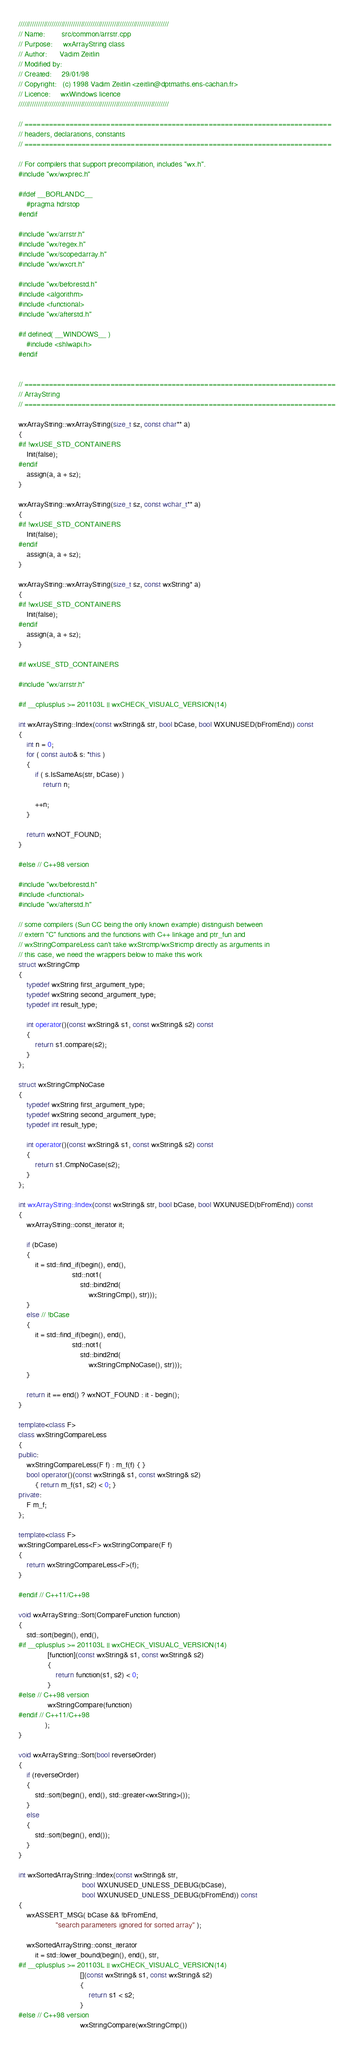<code> <loc_0><loc_0><loc_500><loc_500><_C++_>/////////////////////////////////////////////////////////////////////////////
// Name:        src/common/arrstr.cpp
// Purpose:     wxArrayString class
// Author:      Vadim Zeitlin
// Modified by:
// Created:     29/01/98
// Copyright:   (c) 1998 Vadim Zeitlin <zeitlin@dptmaths.ens-cachan.fr>
// Licence:     wxWindows licence
/////////////////////////////////////////////////////////////////////////////

// ===========================================================================
// headers, declarations, constants
// ===========================================================================

// For compilers that support precompilation, includes "wx.h".
#include "wx/wxprec.h"

#ifdef __BORLANDC__
    #pragma hdrstop
#endif

#include "wx/arrstr.h"
#include "wx/regex.h"
#include "wx/scopedarray.h"
#include "wx/wxcrt.h"

#include "wx/beforestd.h"
#include <algorithm>
#include <functional>
#include "wx/afterstd.h"

#if defined( __WINDOWS__ )
    #include <shlwapi.h>
#endif


// ============================================================================
// ArrayString
// ============================================================================

wxArrayString::wxArrayString(size_t sz, const char** a)
{
#if !wxUSE_STD_CONTAINERS
    Init(false);
#endif
    assign(a, a + sz);
}

wxArrayString::wxArrayString(size_t sz, const wchar_t** a)
{
#if !wxUSE_STD_CONTAINERS
    Init(false);
#endif
    assign(a, a + sz);
}

wxArrayString::wxArrayString(size_t sz, const wxString* a)
{
#if !wxUSE_STD_CONTAINERS
    Init(false);
#endif
    assign(a, a + sz);
}

#if wxUSE_STD_CONTAINERS

#include "wx/arrstr.h"

#if __cplusplus >= 201103L || wxCHECK_VISUALC_VERSION(14)

int wxArrayString::Index(const wxString& str, bool bCase, bool WXUNUSED(bFromEnd)) const
{
    int n = 0;
    for ( const auto& s: *this )
    {
        if ( s.IsSameAs(str, bCase) )
            return n;

        ++n;
    }

    return wxNOT_FOUND;
}

#else // C++98 version

#include "wx/beforestd.h"
#include <functional>
#include "wx/afterstd.h"

// some compilers (Sun CC being the only known example) distinguish between
// extern "C" functions and the functions with C++ linkage and ptr_fun and
// wxStringCompareLess can't take wxStrcmp/wxStricmp directly as arguments in
// this case, we need the wrappers below to make this work
struct wxStringCmp
{
    typedef wxString first_argument_type;
    typedef wxString second_argument_type;
    typedef int result_type;

    int operator()(const wxString& s1, const wxString& s2) const
    {
        return s1.compare(s2);
    }
};

struct wxStringCmpNoCase
{
    typedef wxString first_argument_type;
    typedef wxString second_argument_type;
    typedef int result_type;

    int operator()(const wxString& s1, const wxString& s2) const
    {
        return s1.CmpNoCase(s2);
    }
};

int wxArrayString::Index(const wxString& str, bool bCase, bool WXUNUSED(bFromEnd)) const
{
    wxArrayString::const_iterator it;

    if (bCase)
    {
        it = std::find_if(begin(), end(),
                          std::not1(
                              std::bind2nd(
                                  wxStringCmp(), str)));
    }
    else // !bCase
    {
        it = std::find_if(begin(), end(),
                          std::not1(
                              std::bind2nd(
                                  wxStringCmpNoCase(), str)));
    }

    return it == end() ? wxNOT_FOUND : it - begin();
}

template<class F>
class wxStringCompareLess
{
public:
    wxStringCompareLess(F f) : m_f(f) { }
    bool operator()(const wxString& s1, const wxString& s2)
        { return m_f(s1, s2) < 0; }
private:
    F m_f;
};

template<class F>
wxStringCompareLess<F> wxStringCompare(F f)
{
    return wxStringCompareLess<F>(f);
}

#endif // C++11/C++98

void wxArrayString::Sort(CompareFunction function)
{
    std::sort(begin(), end(),
#if __cplusplus >= 201103L || wxCHECK_VISUALC_VERSION(14)
              [function](const wxString& s1, const wxString& s2)
              {
                  return function(s1, s2) < 0;
              }
#else // C++98 version
              wxStringCompare(function)
#endif // C++11/C++98
             );
}

void wxArrayString::Sort(bool reverseOrder)
{
    if (reverseOrder)
    {
        std::sort(begin(), end(), std::greater<wxString>());
    }
    else
    {
        std::sort(begin(), end());
    }
}

int wxSortedArrayString::Index(const wxString& str,
                               bool WXUNUSED_UNLESS_DEBUG(bCase),
                               bool WXUNUSED_UNLESS_DEBUG(bFromEnd)) const
{
    wxASSERT_MSG( bCase && !bFromEnd,
                  "search parameters ignored for sorted array" );

    wxSortedArrayString::const_iterator
        it = std::lower_bound(begin(), end(), str,
#if __cplusplus >= 201103L || wxCHECK_VISUALC_VERSION(14)
                              [](const wxString& s1, const wxString& s2)
                              {
                                  return s1 < s2;
                              }
#else // C++98 version
                              wxStringCompare(wxStringCmp())</code> 